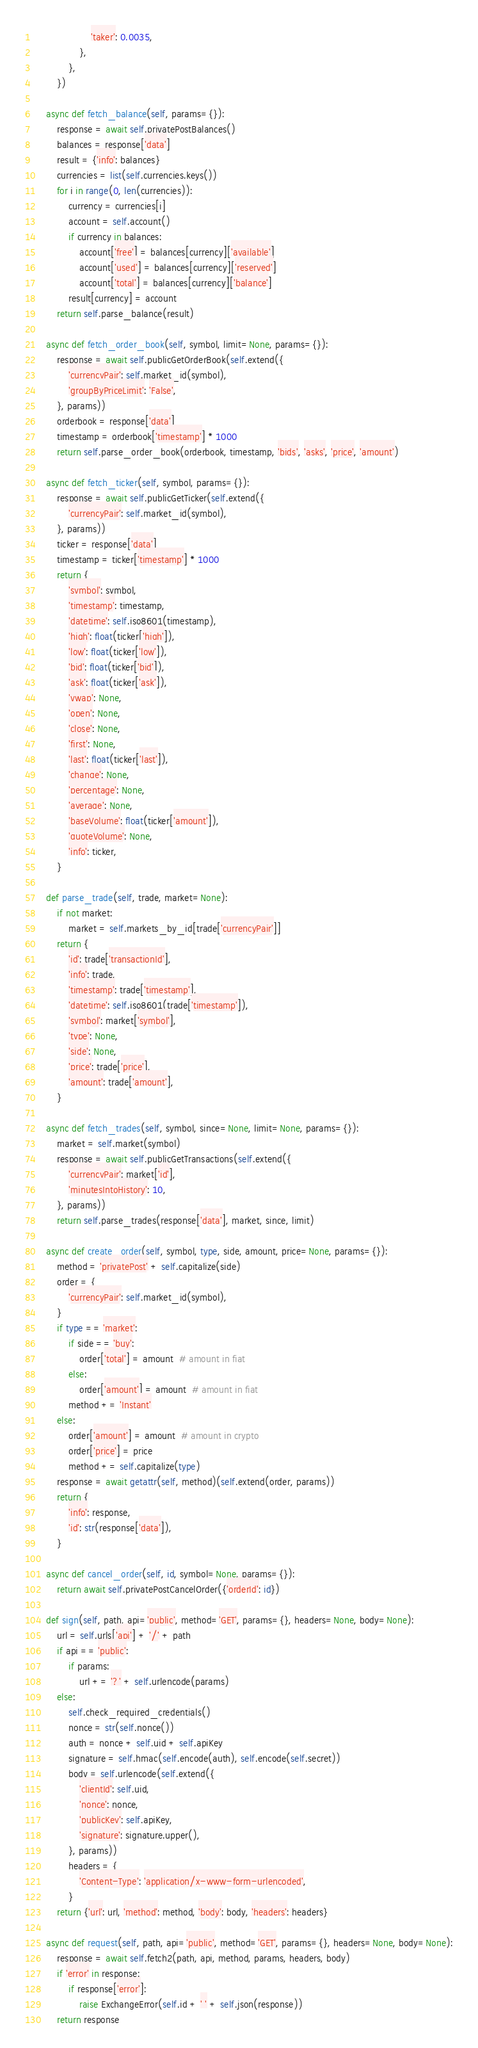Convert code to text. <code><loc_0><loc_0><loc_500><loc_500><_Python_>                    'taker': 0.0035,
                },
            },
        })

    async def fetch_balance(self, params={}):
        response = await self.privatePostBalances()
        balances = response['data']
        result = {'info': balances}
        currencies = list(self.currencies.keys())
        for i in range(0, len(currencies)):
            currency = currencies[i]
            account = self.account()
            if currency in balances:
                account['free'] = balances[currency]['available']
                account['used'] = balances[currency]['reserved']
                account['total'] = balances[currency]['balance']
            result[currency] = account
        return self.parse_balance(result)

    async def fetch_order_book(self, symbol, limit=None, params={}):
        response = await self.publicGetOrderBook(self.extend({
            'currencyPair': self.market_id(symbol),
            'groupByPriceLimit': 'False',
        }, params))
        orderbook = response['data']
        timestamp = orderbook['timestamp'] * 1000
        return self.parse_order_book(orderbook, timestamp, 'bids', 'asks', 'price', 'amount')

    async def fetch_ticker(self, symbol, params={}):
        response = await self.publicGetTicker(self.extend({
            'currencyPair': self.market_id(symbol),
        }, params))
        ticker = response['data']
        timestamp = ticker['timestamp'] * 1000
        return {
            'symbol': symbol,
            'timestamp': timestamp,
            'datetime': self.iso8601(timestamp),
            'high': float(ticker['high']),
            'low': float(ticker['low']),
            'bid': float(ticker['bid']),
            'ask': float(ticker['ask']),
            'vwap': None,
            'open': None,
            'close': None,
            'first': None,
            'last': float(ticker['last']),
            'change': None,
            'percentage': None,
            'average': None,
            'baseVolume': float(ticker['amount']),
            'quoteVolume': None,
            'info': ticker,
        }

    def parse_trade(self, trade, market=None):
        if not market:
            market = self.markets_by_id[trade['currencyPair']]
        return {
            'id': trade['transactionId'],
            'info': trade,
            'timestamp': trade['timestamp'],
            'datetime': self.iso8601(trade['timestamp']),
            'symbol': market['symbol'],
            'type': None,
            'side': None,
            'price': trade['price'],
            'amount': trade['amount'],
        }

    async def fetch_trades(self, symbol, since=None, limit=None, params={}):
        market = self.market(symbol)
        response = await self.publicGetTransactions(self.extend({
            'currencyPair': market['id'],
            'minutesIntoHistory': 10,
        }, params))
        return self.parse_trades(response['data'], market, since, limit)

    async def create_order(self, symbol, type, side, amount, price=None, params={}):
        method = 'privatePost' + self.capitalize(side)
        order = {
            'currencyPair': self.market_id(symbol),
        }
        if type == 'market':
            if side == 'buy':
                order['total'] = amount  # amount in fiat
            else:
                order['amount'] = amount  # amount in fiat
            method += 'Instant'
        else:
            order['amount'] = amount  # amount in crypto
            order['price'] = price
            method += self.capitalize(type)
        response = await getattr(self, method)(self.extend(order, params))
        return {
            'info': response,
            'id': str(response['data']),
        }

    async def cancel_order(self, id, symbol=None, params={}):
        return await self.privatePostCancelOrder({'orderId': id})

    def sign(self, path, api='public', method='GET', params={}, headers=None, body=None):
        url = self.urls['api'] + '/' + path
        if api == 'public':
            if params:
                url += '?' + self.urlencode(params)
        else:
            self.check_required_credentials()
            nonce = str(self.nonce())
            auth = nonce + self.uid + self.apiKey
            signature = self.hmac(self.encode(auth), self.encode(self.secret))
            body = self.urlencode(self.extend({
                'clientId': self.uid,
                'nonce': nonce,
                'publicKey': self.apiKey,
                'signature': signature.upper(),
            }, params))
            headers = {
                'Content-Type': 'application/x-www-form-urlencoded',
            }
        return {'url': url, 'method': method, 'body': body, 'headers': headers}

    async def request(self, path, api='public', method='GET', params={}, headers=None, body=None):
        response = await self.fetch2(path, api, method, params, headers, body)
        if 'error' in response:
            if response['error']:
                raise ExchangeError(self.id + ' ' + self.json(response))
        return response
</code> 